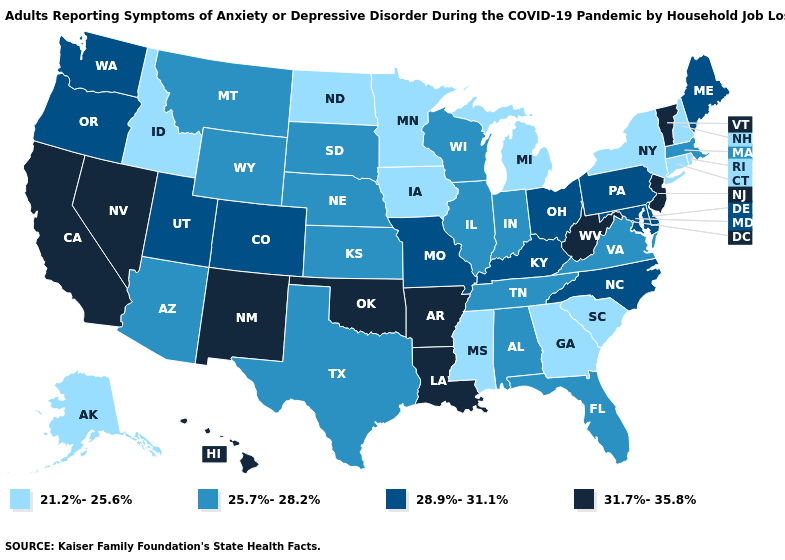Does New Mexico have a lower value than South Carolina?
Answer briefly. No. Does Montana have the lowest value in the West?
Concise answer only. No. Among the states that border Kentucky , which have the lowest value?
Quick response, please. Illinois, Indiana, Tennessee, Virginia. Among the states that border Arizona , which have the lowest value?
Answer briefly. Colorado, Utah. Does the map have missing data?
Write a very short answer. No. Does the map have missing data?
Short answer required. No. Does Arizona have the same value as Kentucky?
Answer briefly. No. What is the highest value in the USA?
Keep it brief. 31.7%-35.8%. What is the value of Oklahoma?
Write a very short answer. 31.7%-35.8%. Name the states that have a value in the range 31.7%-35.8%?
Short answer required. Arkansas, California, Hawaii, Louisiana, Nevada, New Jersey, New Mexico, Oklahoma, Vermont, West Virginia. Among the states that border Texas , which have the highest value?
Give a very brief answer. Arkansas, Louisiana, New Mexico, Oklahoma. What is the value of West Virginia?
Be succinct. 31.7%-35.8%. Which states have the lowest value in the Northeast?
Quick response, please. Connecticut, New Hampshire, New York, Rhode Island. Is the legend a continuous bar?
Be succinct. No. 